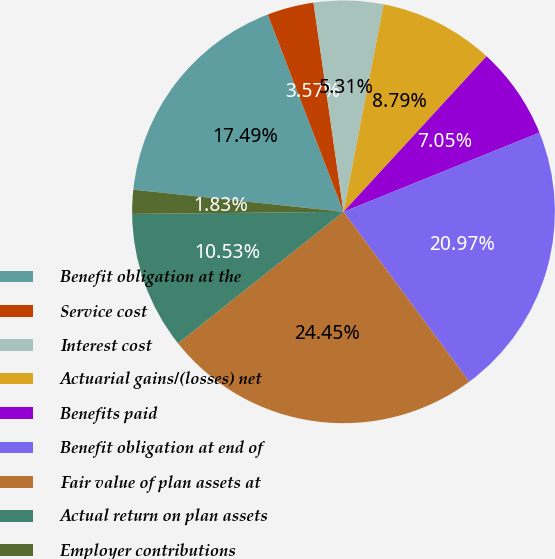Convert chart to OTSL. <chart><loc_0><loc_0><loc_500><loc_500><pie_chart><fcel>Benefit obligation at the<fcel>Service cost<fcel>Interest cost<fcel>Actuarial gains/(losses) net<fcel>Benefits paid<fcel>Benefit obligation at end of<fcel>Fair value of plan assets at<fcel>Actual return on plan assets<fcel>Employer contributions<nl><fcel>17.49%<fcel>3.57%<fcel>5.31%<fcel>8.79%<fcel>7.05%<fcel>20.97%<fcel>24.45%<fcel>10.53%<fcel>1.83%<nl></chart> 